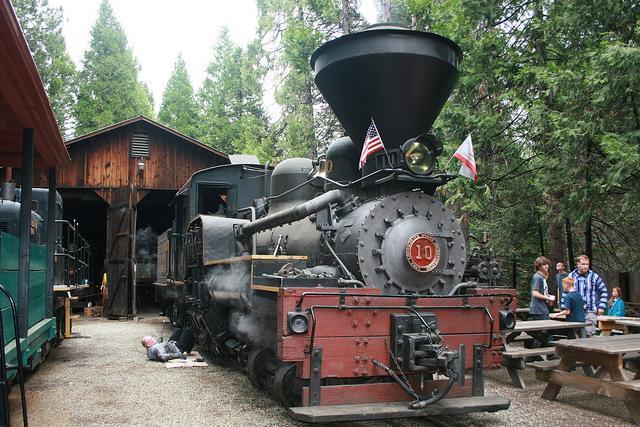How many flags are on the train?
Give a very brief answer. 2. How many benches are in the picture?
Give a very brief answer. 2. How many trains can be seen?
Give a very brief answer. 2. How many birds are pictured?
Give a very brief answer. 0. 